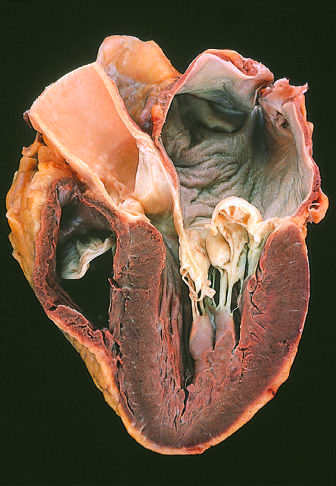s periodic acid-schiff shown on the right in this four-chamber view?
Answer the question using a single word or phrase. No 